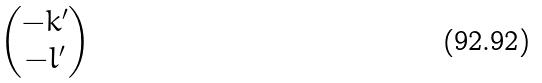Convert formula to latex. <formula><loc_0><loc_0><loc_500><loc_500>\begin{pmatrix} - k ^ { \prime } \\ - l ^ { \prime } \end{pmatrix}</formula> 